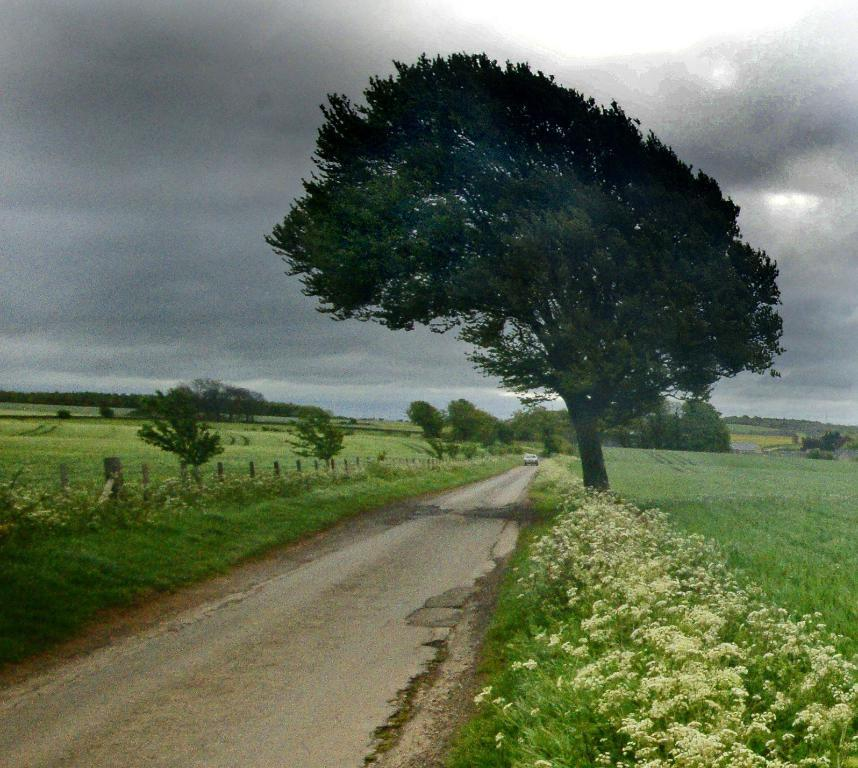What is the main feature of the image? There is a road in the image. What can be seen on either side of the road? There are plants, grass, and trees on either side of the road. What is visible in the sky in the background of the image? There are clouds visible in the sky in the background of the image. What type of gate can be seen blocking the road in the image? There is no gate present in the image; the road is clear and unobstructed. What kind of waste is being disposed of on the side of the road in the image? There is no waste visible in the image; the road and its surroundings are clean and well-maintained. 